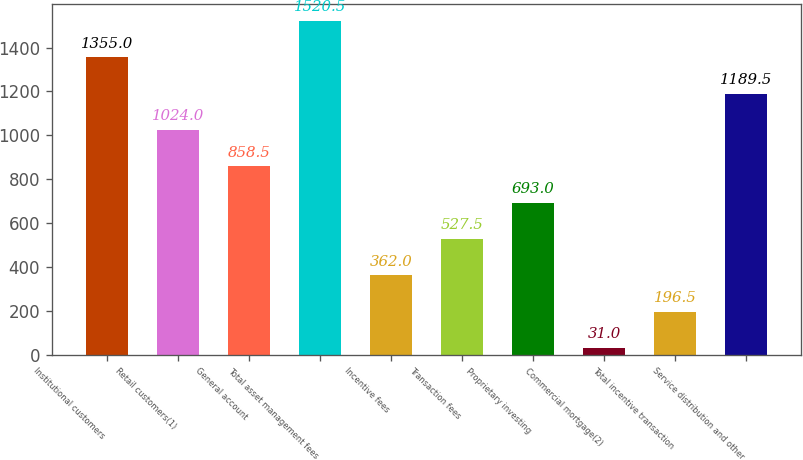Convert chart to OTSL. <chart><loc_0><loc_0><loc_500><loc_500><bar_chart><fcel>Institutional customers<fcel>Retail customers(1)<fcel>General account<fcel>Total asset management fees<fcel>Incentive fees<fcel>Transaction fees<fcel>Proprietary investing<fcel>Commercial mortgage(2)<fcel>Total incentive transaction<fcel>Service distribution and other<nl><fcel>1355<fcel>1024<fcel>858.5<fcel>1520.5<fcel>362<fcel>527.5<fcel>693<fcel>31<fcel>196.5<fcel>1189.5<nl></chart> 